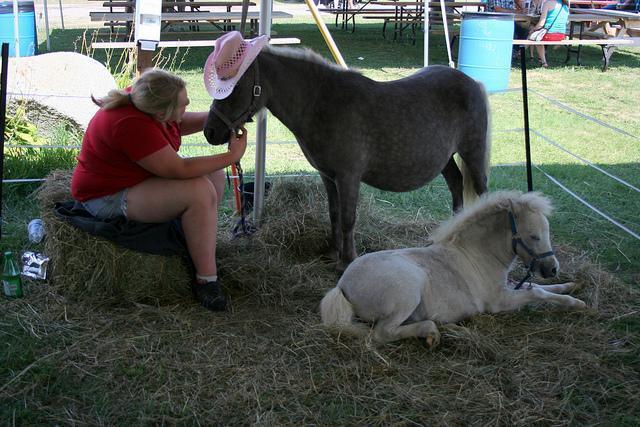How many horses are visible?
Give a very brief answer. 2. How many zebras have stripes?
Give a very brief answer. 0. 